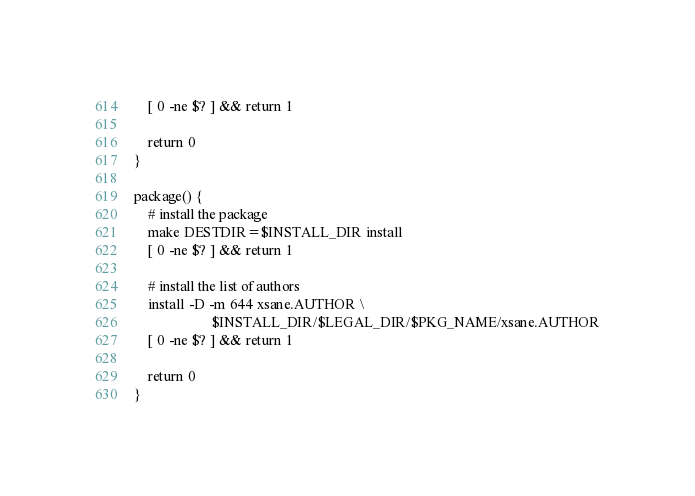<code> <loc_0><loc_0><loc_500><loc_500><_Bash_>	[ 0 -ne $? ] && return 1

	return 0
}

package() {
	# install the package
	make DESTDIR=$INSTALL_DIR install
	[ 0 -ne $? ] && return 1

	# install the list of authors
	install -D -m 644 xsane.AUTHOR \
	                  $INSTALL_DIR/$LEGAL_DIR/$PKG_NAME/xsane.AUTHOR
	[ 0 -ne $? ] && return 1

	return 0
}</code> 